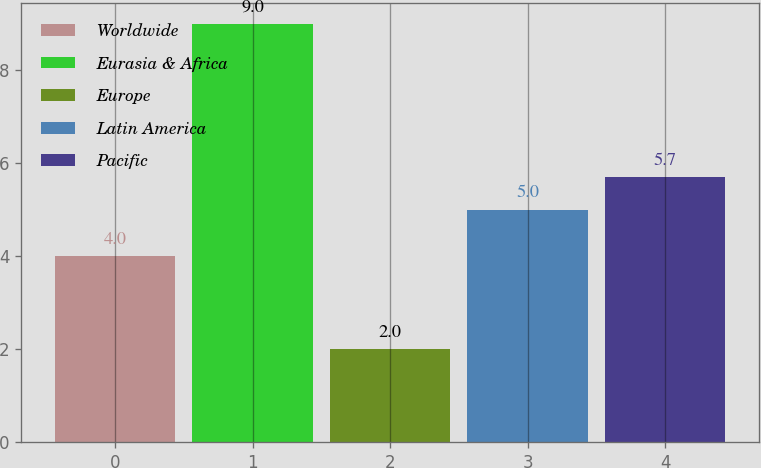Convert chart. <chart><loc_0><loc_0><loc_500><loc_500><bar_chart><fcel>Worldwide<fcel>Eurasia & Africa<fcel>Europe<fcel>Latin America<fcel>Pacific<nl><fcel>4<fcel>9<fcel>2<fcel>5<fcel>5.7<nl></chart> 